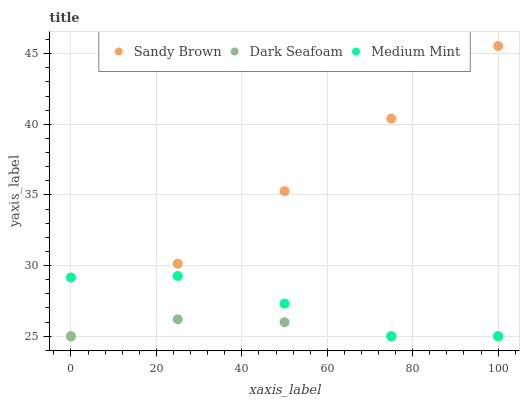Does Dark Seafoam have the minimum area under the curve?
Answer yes or no. Yes. Does Sandy Brown have the maximum area under the curve?
Answer yes or no. Yes. Does Sandy Brown have the minimum area under the curve?
Answer yes or no. No. Does Dark Seafoam have the maximum area under the curve?
Answer yes or no. No. Is Sandy Brown the smoothest?
Answer yes or no. Yes. Is Medium Mint the roughest?
Answer yes or no. Yes. Is Dark Seafoam the smoothest?
Answer yes or no. No. Is Dark Seafoam the roughest?
Answer yes or no. No. Does Medium Mint have the lowest value?
Answer yes or no. Yes. Does Sandy Brown have the highest value?
Answer yes or no. Yes. Does Dark Seafoam have the highest value?
Answer yes or no. No. Does Medium Mint intersect Sandy Brown?
Answer yes or no. Yes. Is Medium Mint less than Sandy Brown?
Answer yes or no. No. Is Medium Mint greater than Sandy Brown?
Answer yes or no. No. 